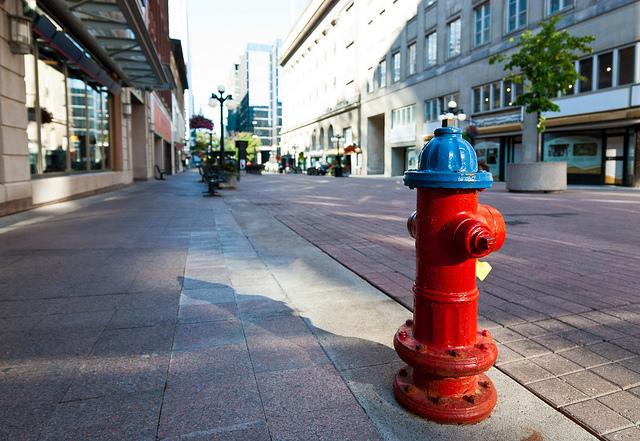What object is red and blue?
Short answer required. Fire hydrant. What type of tree is in the planter?
Be succinct. Maple. Are there any cars on this street?
Give a very brief answer. No. 